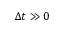Convert formula to latex. <formula><loc_0><loc_0><loc_500><loc_500>\Delta t \gg 0</formula> 